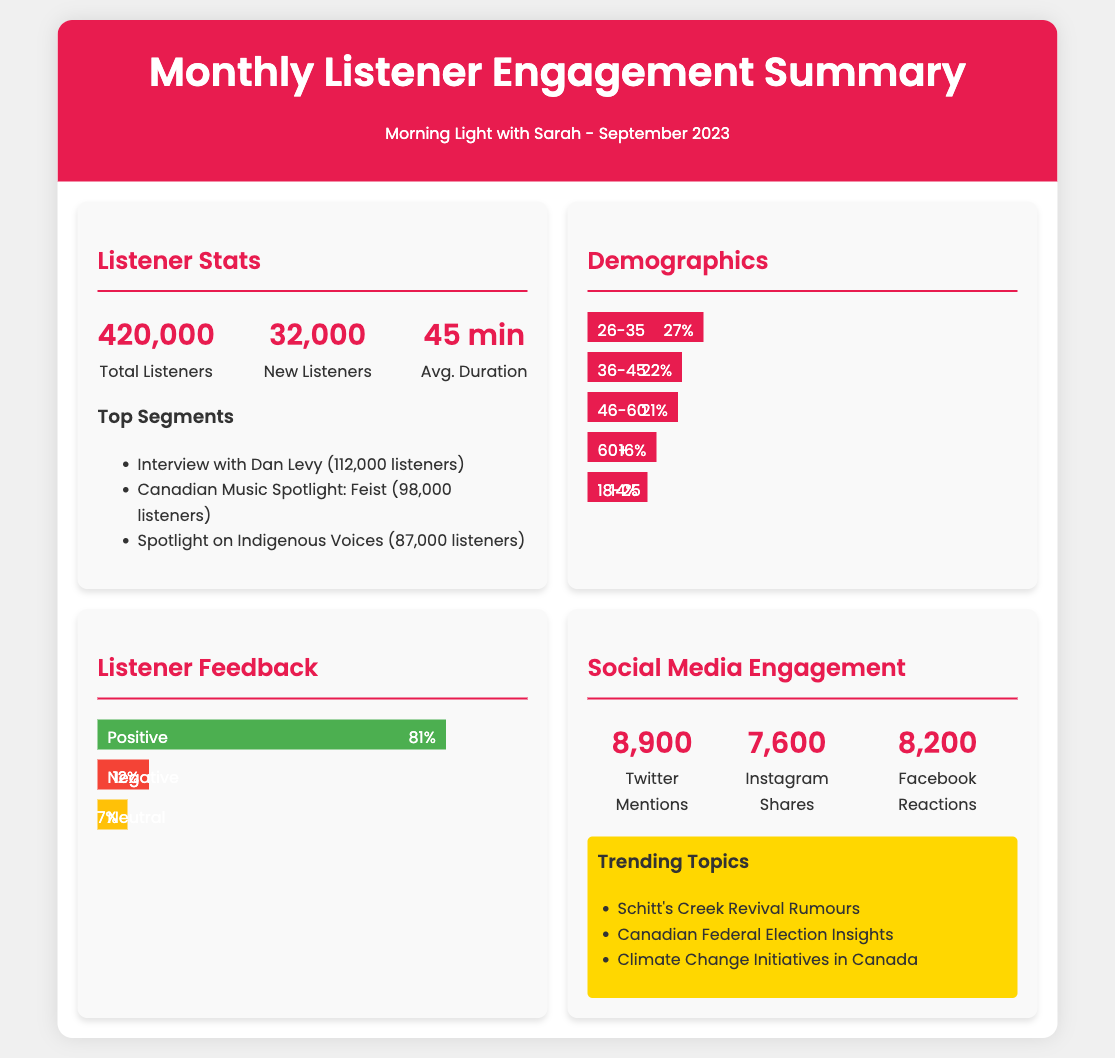What is the total number of listeners? The total number of listeners is explicitly stated in the document as 420,000.
Answer: 420,000 How many new listeners were added? The document states that there were 32,000 new listeners in September 2023.
Answer: 32,000 What was the average listen duration? The average listen duration mentioned in the document is 45 minutes.
Answer: 45 min Which interview was the most listened to segment? The document lists the "Interview with Dan Levy" as the most listened to segment with 112,000 listeners.
Answer: Interview with Dan Levy What percentage of listeners are aged 26-35? The document indicates that 27% of listeners are aged 26-35.
Answer: 27% What was the overall positive feedback percentage? The document shows that the percentage of positive feedback is 81%.
Answer: 81% What is the total number of Twitter mentions? The document specifies that there were 8,900 Twitter mentions.
Answer: 8,900 Which trending topic is related to Schitt's Creek? The document refers to "Schitt's Creek Revival Rumours" as a trending topic.
Answer: Schitt's Creek Revival Rumours How many listeners are aged 60 and above? The document states that 16% of listeners are in the 60+ age group.
Answer: 16% 